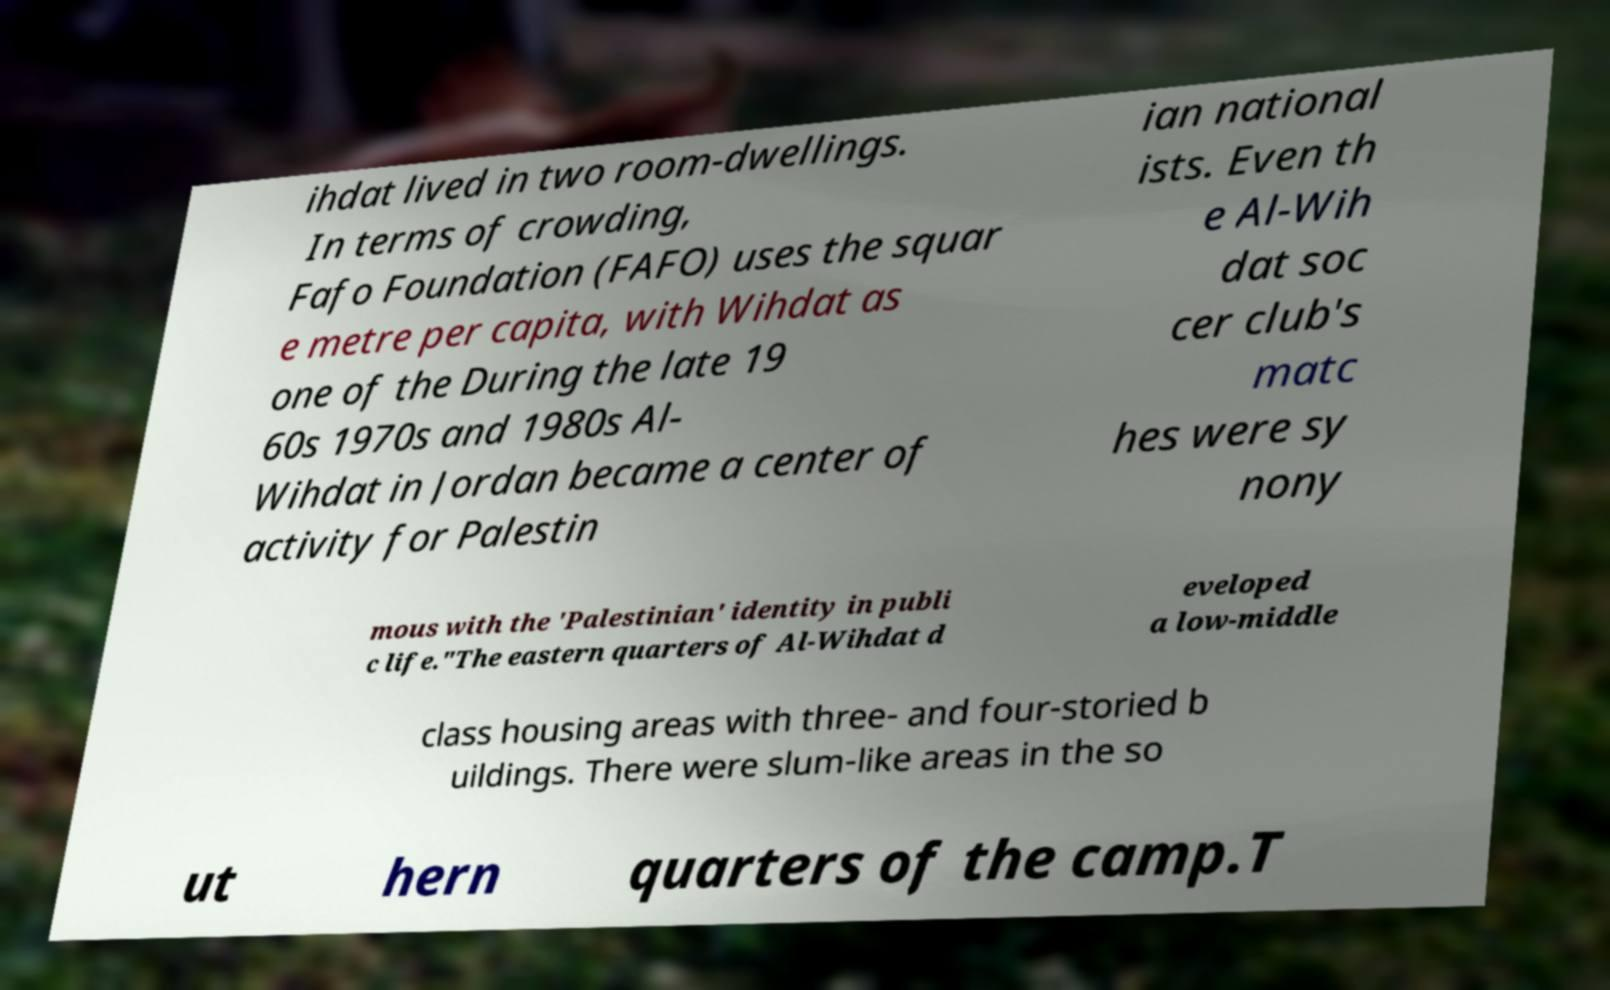Please identify and transcribe the text found in this image. ihdat lived in two room-dwellings. In terms of crowding, Fafo Foundation (FAFO) uses the squar e metre per capita, with Wihdat as one of the During the late 19 60s 1970s and 1980s Al- Wihdat in Jordan became a center of activity for Palestin ian national ists. Even th e Al-Wih dat soc cer club's matc hes were sy nony mous with the 'Palestinian' identity in publi c life."The eastern quarters of Al-Wihdat d eveloped a low-middle class housing areas with three- and four-storied b uildings. There were slum-like areas in the so ut hern quarters of the camp.T 